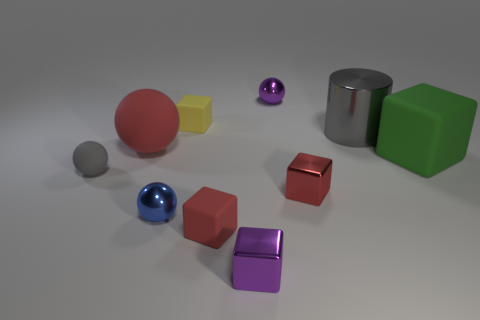Subtract all blue metal balls. How many balls are left? 3 Subtract all purple blocks. How many blocks are left? 4 Subtract all gray cylinders. How many red cubes are left? 2 Subtract 2 balls. How many balls are left? 2 Subtract 1 red balls. How many objects are left? 9 Subtract all cylinders. How many objects are left? 9 Subtract all purple spheres. Subtract all yellow blocks. How many spheres are left? 3 Subtract all large red spheres. Subtract all small rubber things. How many objects are left? 6 Add 2 big shiny objects. How many big shiny objects are left? 3 Add 5 tiny cyan matte cylinders. How many tiny cyan matte cylinders exist? 5 